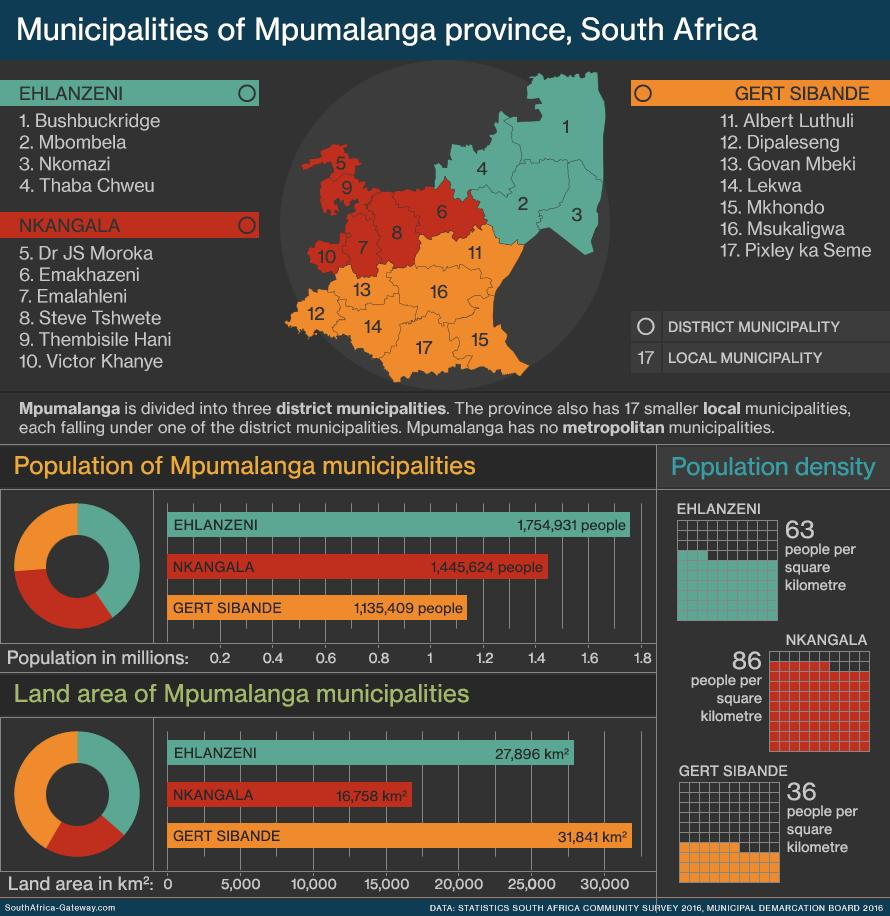Outline some significant characteristics in this image. The color used to represent Nkangala is red. The color orange was previously used to represent Gert Sibande. 